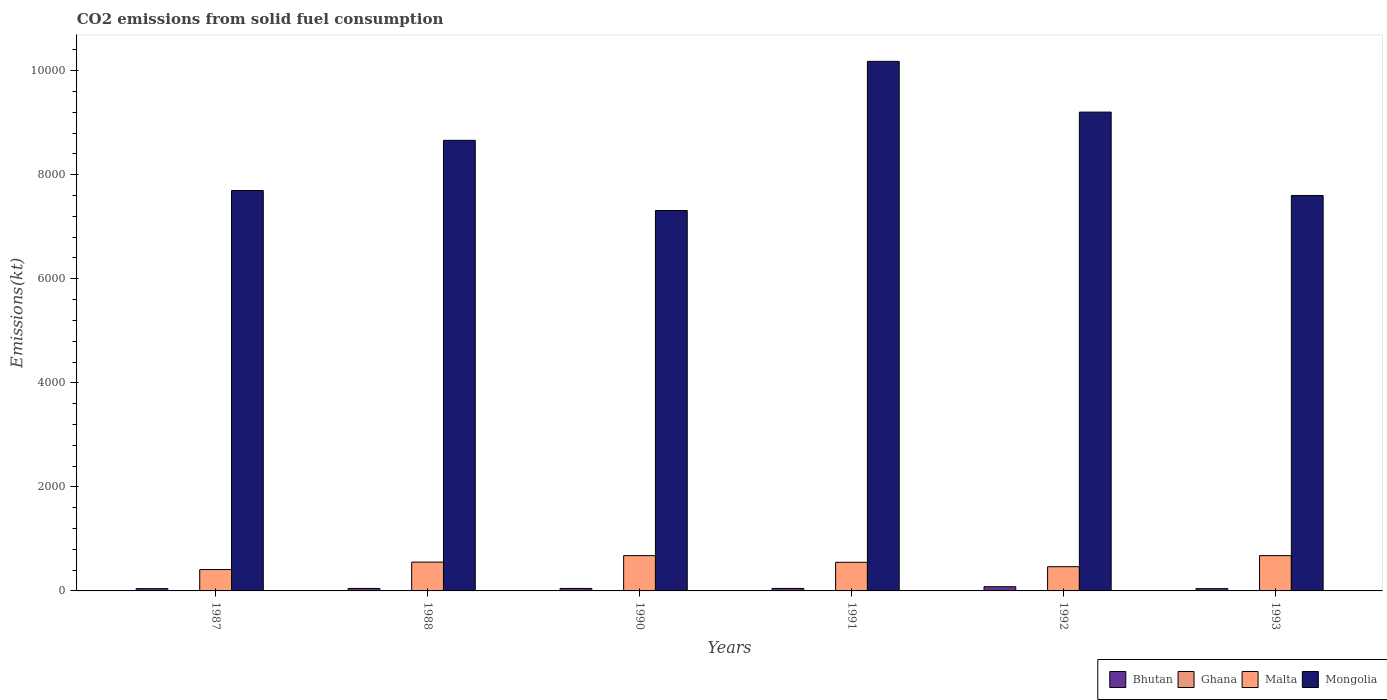How many groups of bars are there?
Your response must be concise. 6. Are the number of bars per tick equal to the number of legend labels?
Your response must be concise. Yes. Are the number of bars on each tick of the X-axis equal?
Make the answer very short. Yes. How many bars are there on the 4th tick from the left?
Give a very brief answer. 4. How many bars are there on the 6th tick from the right?
Offer a terse response. 4. What is the amount of CO2 emitted in Mongolia in 1993?
Your answer should be very brief. 7601.69. Across all years, what is the maximum amount of CO2 emitted in Malta?
Ensure brevity in your answer.  678.39. Across all years, what is the minimum amount of CO2 emitted in Bhutan?
Your answer should be compact. 44. In which year was the amount of CO2 emitted in Bhutan maximum?
Make the answer very short. 1992. What is the total amount of CO2 emitted in Malta in the graph?
Offer a terse response. 3336.97. What is the difference between the amount of CO2 emitted in Malta in 1987 and that in 1988?
Provide a succinct answer. -143.01. What is the difference between the amount of CO2 emitted in Bhutan in 1991 and the amount of CO2 emitted in Ghana in 1990?
Offer a very short reply. 40.34. What is the average amount of CO2 emitted in Bhutan per year?
Your answer should be compact. 51.95. In the year 1993, what is the difference between the amount of CO2 emitted in Bhutan and amount of CO2 emitted in Mongolia?
Make the answer very short. -7557.69. In how many years, is the amount of CO2 emitted in Malta greater than 3200 kt?
Your answer should be compact. 0. What is the ratio of the amount of CO2 emitted in Mongolia in 1990 to that in 1992?
Ensure brevity in your answer.  0.79. Is the difference between the amount of CO2 emitted in Bhutan in 1988 and 1990 greater than the difference between the amount of CO2 emitted in Mongolia in 1988 and 1990?
Your response must be concise. No. What is the difference between the highest and the second highest amount of CO2 emitted in Bhutan?
Offer a very short reply. 33. What is the difference between the highest and the lowest amount of CO2 emitted in Bhutan?
Give a very brief answer. 36.67. In how many years, is the amount of CO2 emitted in Bhutan greater than the average amount of CO2 emitted in Bhutan taken over all years?
Provide a succinct answer. 1. Is the sum of the amount of CO2 emitted in Mongolia in 1988 and 1990 greater than the maximum amount of CO2 emitted in Malta across all years?
Give a very brief answer. Yes. What does the 4th bar from the left in 1993 represents?
Your answer should be compact. Mongolia. What does the 1st bar from the right in 1993 represents?
Offer a terse response. Mongolia. Is it the case that in every year, the sum of the amount of CO2 emitted in Malta and amount of CO2 emitted in Bhutan is greater than the amount of CO2 emitted in Mongolia?
Give a very brief answer. No. Are all the bars in the graph horizontal?
Your response must be concise. No. How many years are there in the graph?
Keep it short and to the point. 6. What is the difference between two consecutive major ticks on the Y-axis?
Keep it short and to the point. 2000. Are the values on the major ticks of Y-axis written in scientific E-notation?
Your response must be concise. No. Does the graph contain grids?
Your response must be concise. No. How are the legend labels stacked?
Give a very brief answer. Horizontal. What is the title of the graph?
Provide a short and direct response. CO2 emissions from solid fuel consumption. Does "Bermuda" appear as one of the legend labels in the graph?
Provide a succinct answer. No. What is the label or title of the Y-axis?
Give a very brief answer. Emissions(kt). What is the Emissions(kt) of Bhutan in 1987?
Your answer should be compact. 44. What is the Emissions(kt) in Ghana in 1987?
Keep it short and to the point. 7.33. What is the Emissions(kt) of Malta in 1987?
Give a very brief answer. 410.7. What is the Emissions(kt) in Mongolia in 1987?
Keep it short and to the point. 7697.03. What is the Emissions(kt) in Bhutan in 1988?
Provide a short and direct response. 47.67. What is the Emissions(kt) of Ghana in 1988?
Offer a terse response. 7.33. What is the Emissions(kt) in Malta in 1988?
Give a very brief answer. 553.72. What is the Emissions(kt) of Mongolia in 1988?
Give a very brief answer. 8661.45. What is the Emissions(kt) in Bhutan in 1990?
Your answer should be compact. 47.67. What is the Emissions(kt) in Ghana in 1990?
Your answer should be compact. 7.33. What is the Emissions(kt) in Malta in 1990?
Your response must be concise. 678.39. What is the Emissions(kt) of Mongolia in 1990?
Provide a short and direct response. 7312. What is the Emissions(kt) of Bhutan in 1991?
Offer a very short reply. 47.67. What is the Emissions(kt) in Ghana in 1991?
Your answer should be very brief. 7.33. What is the Emissions(kt) in Malta in 1991?
Offer a terse response. 550.05. What is the Emissions(kt) in Mongolia in 1991?
Make the answer very short. 1.02e+04. What is the Emissions(kt) in Bhutan in 1992?
Offer a very short reply. 80.67. What is the Emissions(kt) of Ghana in 1992?
Give a very brief answer. 7.33. What is the Emissions(kt) of Malta in 1992?
Make the answer very short. 465.71. What is the Emissions(kt) of Mongolia in 1992?
Give a very brief answer. 9204.17. What is the Emissions(kt) of Bhutan in 1993?
Provide a succinct answer. 44. What is the Emissions(kt) in Ghana in 1993?
Offer a very short reply. 7.33. What is the Emissions(kt) in Malta in 1993?
Keep it short and to the point. 678.39. What is the Emissions(kt) of Mongolia in 1993?
Keep it short and to the point. 7601.69. Across all years, what is the maximum Emissions(kt) in Bhutan?
Your response must be concise. 80.67. Across all years, what is the maximum Emissions(kt) in Ghana?
Provide a succinct answer. 7.33. Across all years, what is the maximum Emissions(kt) in Malta?
Your answer should be very brief. 678.39. Across all years, what is the maximum Emissions(kt) in Mongolia?
Provide a succinct answer. 1.02e+04. Across all years, what is the minimum Emissions(kt) in Bhutan?
Give a very brief answer. 44. Across all years, what is the minimum Emissions(kt) of Ghana?
Offer a terse response. 7.33. Across all years, what is the minimum Emissions(kt) of Malta?
Your answer should be compact. 410.7. Across all years, what is the minimum Emissions(kt) in Mongolia?
Make the answer very short. 7312. What is the total Emissions(kt) in Bhutan in the graph?
Offer a terse response. 311.69. What is the total Emissions(kt) of Ghana in the graph?
Give a very brief answer. 44. What is the total Emissions(kt) of Malta in the graph?
Your answer should be very brief. 3336.97. What is the total Emissions(kt) of Mongolia in the graph?
Your answer should be compact. 5.07e+04. What is the difference between the Emissions(kt) in Bhutan in 1987 and that in 1988?
Provide a short and direct response. -3.67. What is the difference between the Emissions(kt) in Malta in 1987 and that in 1988?
Keep it short and to the point. -143.01. What is the difference between the Emissions(kt) in Mongolia in 1987 and that in 1988?
Give a very brief answer. -964.42. What is the difference between the Emissions(kt) of Bhutan in 1987 and that in 1990?
Offer a terse response. -3.67. What is the difference between the Emissions(kt) in Ghana in 1987 and that in 1990?
Make the answer very short. 0. What is the difference between the Emissions(kt) of Malta in 1987 and that in 1990?
Ensure brevity in your answer.  -267.69. What is the difference between the Emissions(kt) of Mongolia in 1987 and that in 1990?
Your response must be concise. 385.04. What is the difference between the Emissions(kt) of Bhutan in 1987 and that in 1991?
Make the answer very short. -3.67. What is the difference between the Emissions(kt) of Malta in 1987 and that in 1991?
Make the answer very short. -139.35. What is the difference between the Emissions(kt) in Mongolia in 1987 and that in 1991?
Offer a terse response. -2482.56. What is the difference between the Emissions(kt) of Bhutan in 1987 and that in 1992?
Offer a very short reply. -36.67. What is the difference between the Emissions(kt) in Ghana in 1987 and that in 1992?
Your response must be concise. 0. What is the difference between the Emissions(kt) of Malta in 1987 and that in 1992?
Provide a short and direct response. -55.01. What is the difference between the Emissions(kt) in Mongolia in 1987 and that in 1992?
Your answer should be compact. -1507.14. What is the difference between the Emissions(kt) of Malta in 1987 and that in 1993?
Offer a very short reply. -267.69. What is the difference between the Emissions(kt) of Mongolia in 1987 and that in 1993?
Ensure brevity in your answer.  95.34. What is the difference between the Emissions(kt) of Bhutan in 1988 and that in 1990?
Offer a terse response. 0. What is the difference between the Emissions(kt) of Ghana in 1988 and that in 1990?
Keep it short and to the point. 0. What is the difference between the Emissions(kt) in Malta in 1988 and that in 1990?
Your response must be concise. -124.68. What is the difference between the Emissions(kt) in Mongolia in 1988 and that in 1990?
Keep it short and to the point. 1349.46. What is the difference between the Emissions(kt) of Malta in 1988 and that in 1991?
Offer a very short reply. 3.67. What is the difference between the Emissions(kt) of Mongolia in 1988 and that in 1991?
Keep it short and to the point. -1518.14. What is the difference between the Emissions(kt) in Bhutan in 1988 and that in 1992?
Your answer should be compact. -33. What is the difference between the Emissions(kt) of Malta in 1988 and that in 1992?
Make the answer very short. 88.01. What is the difference between the Emissions(kt) in Mongolia in 1988 and that in 1992?
Make the answer very short. -542.72. What is the difference between the Emissions(kt) in Bhutan in 1988 and that in 1993?
Make the answer very short. 3.67. What is the difference between the Emissions(kt) of Malta in 1988 and that in 1993?
Your response must be concise. -124.68. What is the difference between the Emissions(kt) of Mongolia in 1988 and that in 1993?
Provide a succinct answer. 1059.76. What is the difference between the Emissions(kt) of Bhutan in 1990 and that in 1991?
Offer a terse response. 0. What is the difference between the Emissions(kt) of Ghana in 1990 and that in 1991?
Provide a succinct answer. 0. What is the difference between the Emissions(kt) of Malta in 1990 and that in 1991?
Offer a terse response. 128.34. What is the difference between the Emissions(kt) in Mongolia in 1990 and that in 1991?
Ensure brevity in your answer.  -2867.59. What is the difference between the Emissions(kt) of Bhutan in 1990 and that in 1992?
Provide a succinct answer. -33. What is the difference between the Emissions(kt) in Malta in 1990 and that in 1992?
Give a very brief answer. 212.69. What is the difference between the Emissions(kt) in Mongolia in 1990 and that in 1992?
Offer a terse response. -1892.17. What is the difference between the Emissions(kt) in Bhutan in 1990 and that in 1993?
Your answer should be very brief. 3.67. What is the difference between the Emissions(kt) of Ghana in 1990 and that in 1993?
Your answer should be very brief. 0. What is the difference between the Emissions(kt) of Mongolia in 1990 and that in 1993?
Provide a succinct answer. -289.69. What is the difference between the Emissions(kt) in Bhutan in 1991 and that in 1992?
Offer a terse response. -33. What is the difference between the Emissions(kt) in Ghana in 1991 and that in 1992?
Offer a terse response. 0. What is the difference between the Emissions(kt) of Malta in 1991 and that in 1992?
Ensure brevity in your answer.  84.34. What is the difference between the Emissions(kt) in Mongolia in 1991 and that in 1992?
Provide a succinct answer. 975.42. What is the difference between the Emissions(kt) in Bhutan in 1991 and that in 1993?
Keep it short and to the point. 3.67. What is the difference between the Emissions(kt) in Ghana in 1991 and that in 1993?
Keep it short and to the point. 0. What is the difference between the Emissions(kt) of Malta in 1991 and that in 1993?
Offer a terse response. -128.34. What is the difference between the Emissions(kt) of Mongolia in 1991 and that in 1993?
Make the answer very short. 2577.9. What is the difference between the Emissions(kt) of Bhutan in 1992 and that in 1993?
Provide a short and direct response. 36.67. What is the difference between the Emissions(kt) in Malta in 1992 and that in 1993?
Provide a succinct answer. -212.69. What is the difference between the Emissions(kt) in Mongolia in 1992 and that in 1993?
Offer a terse response. 1602.48. What is the difference between the Emissions(kt) of Bhutan in 1987 and the Emissions(kt) of Ghana in 1988?
Your response must be concise. 36.67. What is the difference between the Emissions(kt) of Bhutan in 1987 and the Emissions(kt) of Malta in 1988?
Your response must be concise. -509.71. What is the difference between the Emissions(kt) in Bhutan in 1987 and the Emissions(kt) in Mongolia in 1988?
Your answer should be compact. -8617.45. What is the difference between the Emissions(kt) in Ghana in 1987 and the Emissions(kt) in Malta in 1988?
Make the answer very short. -546.38. What is the difference between the Emissions(kt) of Ghana in 1987 and the Emissions(kt) of Mongolia in 1988?
Your response must be concise. -8654.12. What is the difference between the Emissions(kt) in Malta in 1987 and the Emissions(kt) in Mongolia in 1988?
Provide a succinct answer. -8250.75. What is the difference between the Emissions(kt) of Bhutan in 1987 and the Emissions(kt) of Ghana in 1990?
Provide a succinct answer. 36.67. What is the difference between the Emissions(kt) of Bhutan in 1987 and the Emissions(kt) of Malta in 1990?
Offer a terse response. -634.39. What is the difference between the Emissions(kt) in Bhutan in 1987 and the Emissions(kt) in Mongolia in 1990?
Your answer should be compact. -7267.99. What is the difference between the Emissions(kt) of Ghana in 1987 and the Emissions(kt) of Malta in 1990?
Provide a short and direct response. -671.06. What is the difference between the Emissions(kt) of Ghana in 1987 and the Emissions(kt) of Mongolia in 1990?
Make the answer very short. -7304.66. What is the difference between the Emissions(kt) in Malta in 1987 and the Emissions(kt) in Mongolia in 1990?
Offer a very short reply. -6901.29. What is the difference between the Emissions(kt) in Bhutan in 1987 and the Emissions(kt) in Ghana in 1991?
Make the answer very short. 36.67. What is the difference between the Emissions(kt) in Bhutan in 1987 and the Emissions(kt) in Malta in 1991?
Give a very brief answer. -506.05. What is the difference between the Emissions(kt) of Bhutan in 1987 and the Emissions(kt) of Mongolia in 1991?
Give a very brief answer. -1.01e+04. What is the difference between the Emissions(kt) in Ghana in 1987 and the Emissions(kt) in Malta in 1991?
Give a very brief answer. -542.72. What is the difference between the Emissions(kt) in Ghana in 1987 and the Emissions(kt) in Mongolia in 1991?
Provide a succinct answer. -1.02e+04. What is the difference between the Emissions(kt) in Malta in 1987 and the Emissions(kt) in Mongolia in 1991?
Keep it short and to the point. -9768.89. What is the difference between the Emissions(kt) of Bhutan in 1987 and the Emissions(kt) of Ghana in 1992?
Make the answer very short. 36.67. What is the difference between the Emissions(kt) of Bhutan in 1987 and the Emissions(kt) of Malta in 1992?
Provide a short and direct response. -421.7. What is the difference between the Emissions(kt) of Bhutan in 1987 and the Emissions(kt) of Mongolia in 1992?
Ensure brevity in your answer.  -9160.17. What is the difference between the Emissions(kt) of Ghana in 1987 and the Emissions(kt) of Malta in 1992?
Offer a very short reply. -458.38. What is the difference between the Emissions(kt) in Ghana in 1987 and the Emissions(kt) in Mongolia in 1992?
Your answer should be very brief. -9196.84. What is the difference between the Emissions(kt) of Malta in 1987 and the Emissions(kt) of Mongolia in 1992?
Your answer should be very brief. -8793.47. What is the difference between the Emissions(kt) in Bhutan in 1987 and the Emissions(kt) in Ghana in 1993?
Keep it short and to the point. 36.67. What is the difference between the Emissions(kt) of Bhutan in 1987 and the Emissions(kt) of Malta in 1993?
Offer a very short reply. -634.39. What is the difference between the Emissions(kt) of Bhutan in 1987 and the Emissions(kt) of Mongolia in 1993?
Keep it short and to the point. -7557.69. What is the difference between the Emissions(kt) in Ghana in 1987 and the Emissions(kt) in Malta in 1993?
Keep it short and to the point. -671.06. What is the difference between the Emissions(kt) of Ghana in 1987 and the Emissions(kt) of Mongolia in 1993?
Ensure brevity in your answer.  -7594.36. What is the difference between the Emissions(kt) in Malta in 1987 and the Emissions(kt) in Mongolia in 1993?
Provide a succinct answer. -7190.99. What is the difference between the Emissions(kt) of Bhutan in 1988 and the Emissions(kt) of Ghana in 1990?
Ensure brevity in your answer.  40.34. What is the difference between the Emissions(kt) in Bhutan in 1988 and the Emissions(kt) in Malta in 1990?
Ensure brevity in your answer.  -630.72. What is the difference between the Emissions(kt) of Bhutan in 1988 and the Emissions(kt) of Mongolia in 1990?
Your answer should be very brief. -7264.33. What is the difference between the Emissions(kt) of Ghana in 1988 and the Emissions(kt) of Malta in 1990?
Ensure brevity in your answer.  -671.06. What is the difference between the Emissions(kt) in Ghana in 1988 and the Emissions(kt) in Mongolia in 1990?
Your answer should be very brief. -7304.66. What is the difference between the Emissions(kt) in Malta in 1988 and the Emissions(kt) in Mongolia in 1990?
Offer a terse response. -6758.28. What is the difference between the Emissions(kt) of Bhutan in 1988 and the Emissions(kt) of Ghana in 1991?
Offer a terse response. 40.34. What is the difference between the Emissions(kt) in Bhutan in 1988 and the Emissions(kt) in Malta in 1991?
Your response must be concise. -502.38. What is the difference between the Emissions(kt) in Bhutan in 1988 and the Emissions(kt) in Mongolia in 1991?
Your response must be concise. -1.01e+04. What is the difference between the Emissions(kt) in Ghana in 1988 and the Emissions(kt) in Malta in 1991?
Your answer should be very brief. -542.72. What is the difference between the Emissions(kt) in Ghana in 1988 and the Emissions(kt) in Mongolia in 1991?
Your answer should be compact. -1.02e+04. What is the difference between the Emissions(kt) of Malta in 1988 and the Emissions(kt) of Mongolia in 1991?
Ensure brevity in your answer.  -9625.88. What is the difference between the Emissions(kt) in Bhutan in 1988 and the Emissions(kt) in Ghana in 1992?
Keep it short and to the point. 40.34. What is the difference between the Emissions(kt) in Bhutan in 1988 and the Emissions(kt) in Malta in 1992?
Your answer should be compact. -418.04. What is the difference between the Emissions(kt) in Bhutan in 1988 and the Emissions(kt) in Mongolia in 1992?
Ensure brevity in your answer.  -9156.5. What is the difference between the Emissions(kt) in Ghana in 1988 and the Emissions(kt) in Malta in 1992?
Offer a terse response. -458.38. What is the difference between the Emissions(kt) of Ghana in 1988 and the Emissions(kt) of Mongolia in 1992?
Provide a short and direct response. -9196.84. What is the difference between the Emissions(kt) in Malta in 1988 and the Emissions(kt) in Mongolia in 1992?
Provide a short and direct response. -8650.45. What is the difference between the Emissions(kt) of Bhutan in 1988 and the Emissions(kt) of Ghana in 1993?
Provide a succinct answer. 40.34. What is the difference between the Emissions(kt) of Bhutan in 1988 and the Emissions(kt) of Malta in 1993?
Make the answer very short. -630.72. What is the difference between the Emissions(kt) in Bhutan in 1988 and the Emissions(kt) in Mongolia in 1993?
Offer a very short reply. -7554.02. What is the difference between the Emissions(kt) of Ghana in 1988 and the Emissions(kt) of Malta in 1993?
Offer a very short reply. -671.06. What is the difference between the Emissions(kt) of Ghana in 1988 and the Emissions(kt) of Mongolia in 1993?
Provide a succinct answer. -7594.36. What is the difference between the Emissions(kt) of Malta in 1988 and the Emissions(kt) of Mongolia in 1993?
Ensure brevity in your answer.  -7047.97. What is the difference between the Emissions(kt) of Bhutan in 1990 and the Emissions(kt) of Ghana in 1991?
Keep it short and to the point. 40.34. What is the difference between the Emissions(kt) of Bhutan in 1990 and the Emissions(kt) of Malta in 1991?
Provide a short and direct response. -502.38. What is the difference between the Emissions(kt) in Bhutan in 1990 and the Emissions(kt) in Mongolia in 1991?
Provide a succinct answer. -1.01e+04. What is the difference between the Emissions(kt) in Ghana in 1990 and the Emissions(kt) in Malta in 1991?
Provide a succinct answer. -542.72. What is the difference between the Emissions(kt) of Ghana in 1990 and the Emissions(kt) of Mongolia in 1991?
Your answer should be compact. -1.02e+04. What is the difference between the Emissions(kt) of Malta in 1990 and the Emissions(kt) of Mongolia in 1991?
Give a very brief answer. -9501.2. What is the difference between the Emissions(kt) of Bhutan in 1990 and the Emissions(kt) of Ghana in 1992?
Your answer should be compact. 40.34. What is the difference between the Emissions(kt) in Bhutan in 1990 and the Emissions(kt) in Malta in 1992?
Provide a succinct answer. -418.04. What is the difference between the Emissions(kt) of Bhutan in 1990 and the Emissions(kt) of Mongolia in 1992?
Provide a short and direct response. -9156.5. What is the difference between the Emissions(kt) of Ghana in 1990 and the Emissions(kt) of Malta in 1992?
Your answer should be compact. -458.38. What is the difference between the Emissions(kt) in Ghana in 1990 and the Emissions(kt) in Mongolia in 1992?
Your answer should be very brief. -9196.84. What is the difference between the Emissions(kt) in Malta in 1990 and the Emissions(kt) in Mongolia in 1992?
Provide a short and direct response. -8525.77. What is the difference between the Emissions(kt) of Bhutan in 1990 and the Emissions(kt) of Ghana in 1993?
Provide a short and direct response. 40.34. What is the difference between the Emissions(kt) in Bhutan in 1990 and the Emissions(kt) in Malta in 1993?
Offer a very short reply. -630.72. What is the difference between the Emissions(kt) in Bhutan in 1990 and the Emissions(kt) in Mongolia in 1993?
Keep it short and to the point. -7554.02. What is the difference between the Emissions(kt) in Ghana in 1990 and the Emissions(kt) in Malta in 1993?
Your answer should be very brief. -671.06. What is the difference between the Emissions(kt) of Ghana in 1990 and the Emissions(kt) of Mongolia in 1993?
Ensure brevity in your answer.  -7594.36. What is the difference between the Emissions(kt) in Malta in 1990 and the Emissions(kt) in Mongolia in 1993?
Offer a terse response. -6923.3. What is the difference between the Emissions(kt) in Bhutan in 1991 and the Emissions(kt) in Ghana in 1992?
Your response must be concise. 40.34. What is the difference between the Emissions(kt) of Bhutan in 1991 and the Emissions(kt) of Malta in 1992?
Offer a terse response. -418.04. What is the difference between the Emissions(kt) of Bhutan in 1991 and the Emissions(kt) of Mongolia in 1992?
Provide a short and direct response. -9156.5. What is the difference between the Emissions(kt) in Ghana in 1991 and the Emissions(kt) in Malta in 1992?
Provide a succinct answer. -458.38. What is the difference between the Emissions(kt) in Ghana in 1991 and the Emissions(kt) in Mongolia in 1992?
Your answer should be very brief. -9196.84. What is the difference between the Emissions(kt) in Malta in 1991 and the Emissions(kt) in Mongolia in 1992?
Your answer should be very brief. -8654.12. What is the difference between the Emissions(kt) in Bhutan in 1991 and the Emissions(kt) in Ghana in 1993?
Give a very brief answer. 40.34. What is the difference between the Emissions(kt) in Bhutan in 1991 and the Emissions(kt) in Malta in 1993?
Provide a short and direct response. -630.72. What is the difference between the Emissions(kt) of Bhutan in 1991 and the Emissions(kt) of Mongolia in 1993?
Ensure brevity in your answer.  -7554.02. What is the difference between the Emissions(kt) in Ghana in 1991 and the Emissions(kt) in Malta in 1993?
Your response must be concise. -671.06. What is the difference between the Emissions(kt) of Ghana in 1991 and the Emissions(kt) of Mongolia in 1993?
Keep it short and to the point. -7594.36. What is the difference between the Emissions(kt) in Malta in 1991 and the Emissions(kt) in Mongolia in 1993?
Make the answer very short. -7051.64. What is the difference between the Emissions(kt) in Bhutan in 1992 and the Emissions(kt) in Ghana in 1993?
Provide a succinct answer. 73.34. What is the difference between the Emissions(kt) of Bhutan in 1992 and the Emissions(kt) of Malta in 1993?
Your answer should be compact. -597.72. What is the difference between the Emissions(kt) of Bhutan in 1992 and the Emissions(kt) of Mongolia in 1993?
Give a very brief answer. -7521.02. What is the difference between the Emissions(kt) of Ghana in 1992 and the Emissions(kt) of Malta in 1993?
Your answer should be very brief. -671.06. What is the difference between the Emissions(kt) in Ghana in 1992 and the Emissions(kt) in Mongolia in 1993?
Provide a succinct answer. -7594.36. What is the difference between the Emissions(kt) in Malta in 1992 and the Emissions(kt) in Mongolia in 1993?
Keep it short and to the point. -7135.98. What is the average Emissions(kt) in Bhutan per year?
Your answer should be compact. 51.95. What is the average Emissions(kt) of Ghana per year?
Make the answer very short. 7.33. What is the average Emissions(kt) in Malta per year?
Make the answer very short. 556.16. What is the average Emissions(kt) of Mongolia per year?
Offer a very short reply. 8442.66. In the year 1987, what is the difference between the Emissions(kt) of Bhutan and Emissions(kt) of Ghana?
Provide a short and direct response. 36.67. In the year 1987, what is the difference between the Emissions(kt) of Bhutan and Emissions(kt) of Malta?
Your answer should be very brief. -366.7. In the year 1987, what is the difference between the Emissions(kt) in Bhutan and Emissions(kt) in Mongolia?
Offer a terse response. -7653.03. In the year 1987, what is the difference between the Emissions(kt) in Ghana and Emissions(kt) in Malta?
Provide a succinct answer. -403.37. In the year 1987, what is the difference between the Emissions(kt) of Ghana and Emissions(kt) of Mongolia?
Your answer should be very brief. -7689.7. In the year 1987, what is the difference between the Emissions(kt) in Malta and Emissions(kt) in Mongolia?
Give a very brief answer. -7286.33. In the year 1988, what is the difference between the Emissions(kt) in Bhutan and Emissions(kt) in Ghana?
Give a very brief answer. 40.34. In the year 1988, what is the difference between the Emissions(kt) in Bhutan and Emissions(kt) in Malta?
Keep it short and to the point. -506.05. In the year 1988, what is the difference between the Emissions(kt) in Bhutan and Emissions(kt) in Mongolia?
Offer a terse response. -8613.78. In the year 1988, what is the difference between the Emissions(kt) in Ghana and Emissions(kt) in Malta?
Give a very brief answer. -546.38. In the year 1988, what is the difference between the Emissions(kt) in Ghana and Emissions(kt) in Mongolia?
Give a very brief answer. -8654.12. In the year 1988, what is the difference between the Emissions(kt) in Malta and Emissions(kt) in Mongolia?
Your response must be concise. -8107.74. In the year 1990, what is the difference between the Emissions(kt) in Bhutan and Emissions(kt) in Ghana?
Provide a short and direct response. 40.34. In the year 1990, what is the difference between the Emissions(kt) of Bhutan and Emissions(kt) of Malta?
Offer a terse response. -630.72. In the year 1990, what is the difference between the Emissions(kt) in Bhutan and Emissions(kt) in Mongolia?
Offer a very short reply. -7264.33. In the year 1990, what is the difference between the Emissions(kt) in Ghana and Emissions(kt) in Malta?
Offer a very short reply. -671.06. In the year 1990, what is the difference between the Emissions(kt) in Ghana and Emissions(kt) in Mongolia?
Keep it short and to the point. -7304.66. In the year 1990, what is the difference between the Emissions(kt) of Malta and Emissions(kt) of Mongolia?
Provide a short and direct response. -6633.6. In the year 1991, what is the difference between the Emissions(kt) of Bhutan and Emissions(kt) of Ghana?
Your answer should be compact. 40.34. In the year 1991, what is the difference between the Emissions(kt) of Bhutan and Emissions(kt) of Malta?
Offer a very short reply. -502.38. In the year 1991, what is the difference between the Emissions(kt) of Bhutan and Emissions(kt) of Mongolia?
Your answer should be compact. -1.01e+04. In the year 1991, what is the difference between the Emissions(kt) in Ghana and Emissions(kt) in Malta?
Provide a succinct answer. -542.72. In the year 1991, what is the difference between the Emissions(kt) in Ghana and Emissions(kt) in Mongolia?
Offer a terse response. -1.02e+04. In the year 1991, what is the difference between the Emissions(kt) in Malta and Emissions(kt) in Mongolia?
Offer a terse response. -9629.54. In the year 1992, what is the difference between the Emissions(kt) of Bhutan and Emissions(kt) of Ghana?
Offer a very short reply. 73.34. In the year 1992, what is the difference between the Emissions(kt) in Bhutan and Emissions(kt) in Malta?
Your response must be concise. -385.04. In the year 1992, what is the difference between the Emissions(kt) of Bhutan and Emissions(kt) of Mongolia?
Your answer should be compact. -9123.5. In the year 1992, what is the difference between the Emissions(kt) of Ghana and Emissions(kt) of Malta?
Your answer should be compact. -458.38. In the year 1992, what is the difference between the Emissions(kt) in Ghana and Emissions(kt) in Mongolia?
Make the answer very short. -9196.84. In the year 1992, what is the difference between the Emissions(kt) of Malta and Emissions(kt) of Mongolia?
Ensure brevity in your answer.  -8738.46. In the year 1993, what is the difference between the Emissions(kt) of Bhutan and Emissions(kt) of Ghana?
Make the answer very short. 36.67. In the year 1993, what is the difference between the Emissions(kt) in Bhutan and Emissions(kt) in Malta?
Offer a very short reply. -634.39. In the year 1993, what is the difference between the Emissions(kt) in Bhutan and Emissions(kt) in Mongolia?
Keep it short and to the point. -7557.69. In the year 1993, what is the difference between the Emissions(kt) in Ghana and Emissions(kt) in Malta?
Keep it short and to the point. -671.06. In the year 1993, what is the difference between the Emissions(kt) of Ghana and Emissions(kt) of Mongolia?
Ensure brevity in your answer.  -7594.36. In the year 1993, what is the difference between the Emissions(kt) in Malta and Emissions(kt) in Mongolia?
Your answer should be very brief. -6923.3. What is the ratio of the Emissions(kt) of Bhutan in 1987 to that in 1988?
Offer a terse response. 0.92. What is the ratio of the Emissions(kt) of Malta in 1987 to that in 1988?
Give a very brief answer. 0.74. What is the ratio of the Emissions(kt) of Mongolia in 1987 to that in 1988?
Ensure brevity in your answer.  0.89. What is the ratio of the Emissions(kt) in Bhutan in 1987 to that in 1990?
Ensure brevity in your answer.  0.92. What is the ratio of the Emissions(kt) of Malta in 1987 to that in 1990?
Give a very brief answer. 0.61. What is the ratio of the Emissions(kt) of Mongolia in 1987 to that in 1990?
Give a very brief answer. 1.05. What is the ratio of the Emissions(kt) of Ghana in 1987 to that in 1991?
Give a very brief answer. 1. What is the ratio of the Emissions(kt) in Malta in 1987 to that in 1991?
Provide a short and direct response. 0.75. What is the ratio of the Emissions(kt) in Mongolia in 1987 to that in 1991?
Ensure brevity in your answer.  0.76. What is the ratio of the Emissions(kt) of Bhutan in 1987 to that in 1992?
Offer a terse response. 0.55. What is the ratio of the Emissions(kt) in Ghana in 1987 to that in 1992?
Your answer should be very brief. 1. What is the ratio of the Emissions(kt) of Malta in 1987 to that in 1992?
Provide a short and direct response. 0.88. What is the ratio of the Emissions(kt) in Mongolia in 1987 to that in 1992?
Offer a very short reply. 0.84. What is the ratio of the Emissions(kt) of Bhutan in 1987 to that in 1993?
Your answer should be very brief. 1. What is the ratio of the Emissions(kt) in Malta in 1987 to that in 1993?
Provide a short and direct response. 0.61. What is the ratio of the Emissions(kt) of Mongolia in 1987 to that in 1993?
Your response must be concise. 1.01. What is the ratio of the Emissions(kt) of Ghana in 1988 to that in 1990?
Make the answer very short. 1. What is the ratio of the Emissions(kt) in Malta in 1988 to that in 1990?
Your answer should be compact. 0.82. What is the ratio of the Emissions(kt) in Mongolia in 1988 to that in 1990?
Make the answer very short. 1.18. What is the ratio of the Emissions(kt) in Mongolia in 1988 to that in 1991?
Make the answer very short. 0.85. What is the ratio of the Emissions(kt) in Bhutan in 1988 to that in 1992?
Provide a succinct answer. 0.59. What is the ratio of the Emissions(kt) of Ghana in 1988 to that in 1992?
Your response must be concise. 1. What is the ratio of the Emissions(kt) in Malta in 1988 to that in 1992?
Provide a succinct answer. 1.19. What is the ratio of the Emissions(kt) in Mongolia in 1988 to that in 1992?
Ensure brevity in your answer.  0.94. What is the ratio of the Emissions(kt) in Bhutan in 1988 to that in 1993?
Your response must be concise. 1.08. What is the ratio of the Emissions(kt) of Malta in 1988 to that in 1993?
Provide a short and direct response. 0.82. What is the ratio of the Emissions(kt) of Mongolia in 1988 to that in 1993?
Your response must be concise. 1.14. What is the ratio of the Emissions(kt) of Bhutan in 1990 to that in 1991?
Give a very brief answer. 1. What is the ratio of the Emissions(kt) in Ghana in 1990 to that in 1991?
Your answer should be very brief. 1. What is the ratio of the Emissions(kt) of Malta in 1990 to that in 1991?
Give a very brief answer. 1.23. What is the ratio of the Emissions(kt) of Mongolia in 1990 to that in 1991?
Offer a terse response. 0.72. What is the ratio of the Emissions(kt) in Bhutan in 1990 to that in 1992?
Your answer should be compact. 0.59. What is the ratio of the Emissions(kt) of Ghana in 1990 to that in 1992?
Keep it short and to the point. 1. What is the ratio of the Emissions(kt) in Malta in 1990 to that in 1992?
Make the answer very short. 1.46. What is the ratio of the Emissions(kt) in Mongolia in 1990 to that in 1992?
Keep it short and to the point. 0.79. What is the ratio of the Emissions(kt) of Bhutan in 1990 to that in 1993?
Offer a very short reply. 1.08. What is the ratio of the Emissions(kt) of Mongolia in 1990 to that in 1993?
Make the answer very short. 0.96. What is the ratio of the Emissions(kt) of Bhutan in 1991 to that in 1992?
Offer a very short reply. 0.59. What is the ratio of the Emissions(kt) of Malta in 1991 to that in 1992?
Your answer should be compact. 1.18. What is the ratio of the Emissions(kt) in Mongolia in 1991 to that in 1992?
Keep it short and to the point. 1.11. What is the ratio of the Emissions(kt) of Ghana in 1991 to that in 1993?
Make the answer very short. 1. What is the ratio of the Emissions(kt) of Malta in 1991 to that in 1993?
Your response must be concise. 0.81. What is the ratio of the Emissions(kt) in Mongolia in 1991 to that in 1993?
Offer a very short reply. 1.34. What is the ratio of the Emissions(kt) in Bhutan in 1992 to that in 1993?
Your answer should be very brief. 1.83. What is the ratio of the Emissions(kt) of Ghana in 1992 to that in 1993?
Offer a terse response. 1. What is the ratio of the Emissions(kt) of Malta in 1992 to that in 1993?
Give a very brief answer. 0.69. What is the ratio of the Emissions(kt) of Mongolia in 1992 to that in 1993?
Provide a short and direct response. 1.21. What is the difference between the highest and the second highest Emissions(kt) in Bhutan?
Provide a short and direct response. 33. What is the difference between the highest and the second highest Emissions(kt) in Ghana?
Keep it short and to the point. 0. What is the difference between the highest and the second highest Emissions(kt) of Malta?
Your response must be concise. 0. What is the difference between the highest and the second highest Emissions(kt) in Mongolia?
Provide a short and direct response. 975.42. What is the difference between the highest and the lowest Emissions(kt) of Bhutan?
Ensure brevity in your answer.  36.67. What is the difference between the highest and the lowest Emissions(kt) of Ghana?
Offer a very short reply. 0. What is the difference between the highest and the lowest Emissions(kt) in Malta?
Your answer should be very brief. 267.69. What is the difference between the highest and the lowest Emissions(kt) in Mongolia?
Your response must be concise. 2867.59. 